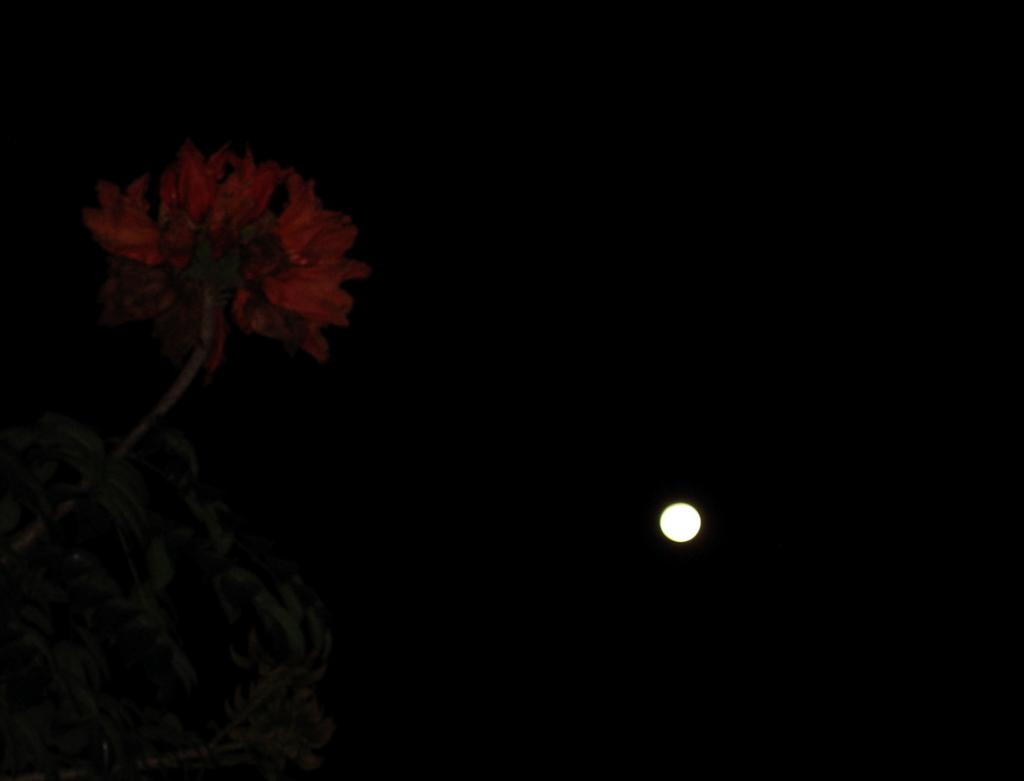What celestial object is visible in the image? There is a moon in the image. Where is the moon located in the image? The moon is at the bottom side of the image. What type of plant is present in the image? There is a flower in the image. On which side of the image is the flower located? The flower is on the left side of the image. What time of day does the image appear to be captured? The image appears to be captured during night time. How many babies are being born in the garden in the image? There is no garden or babies present in the image; it features a moon and a flower. What is the flower in the image trying to get the attention of? The image does not suggest that the flower is trying to get anyone's attention. 